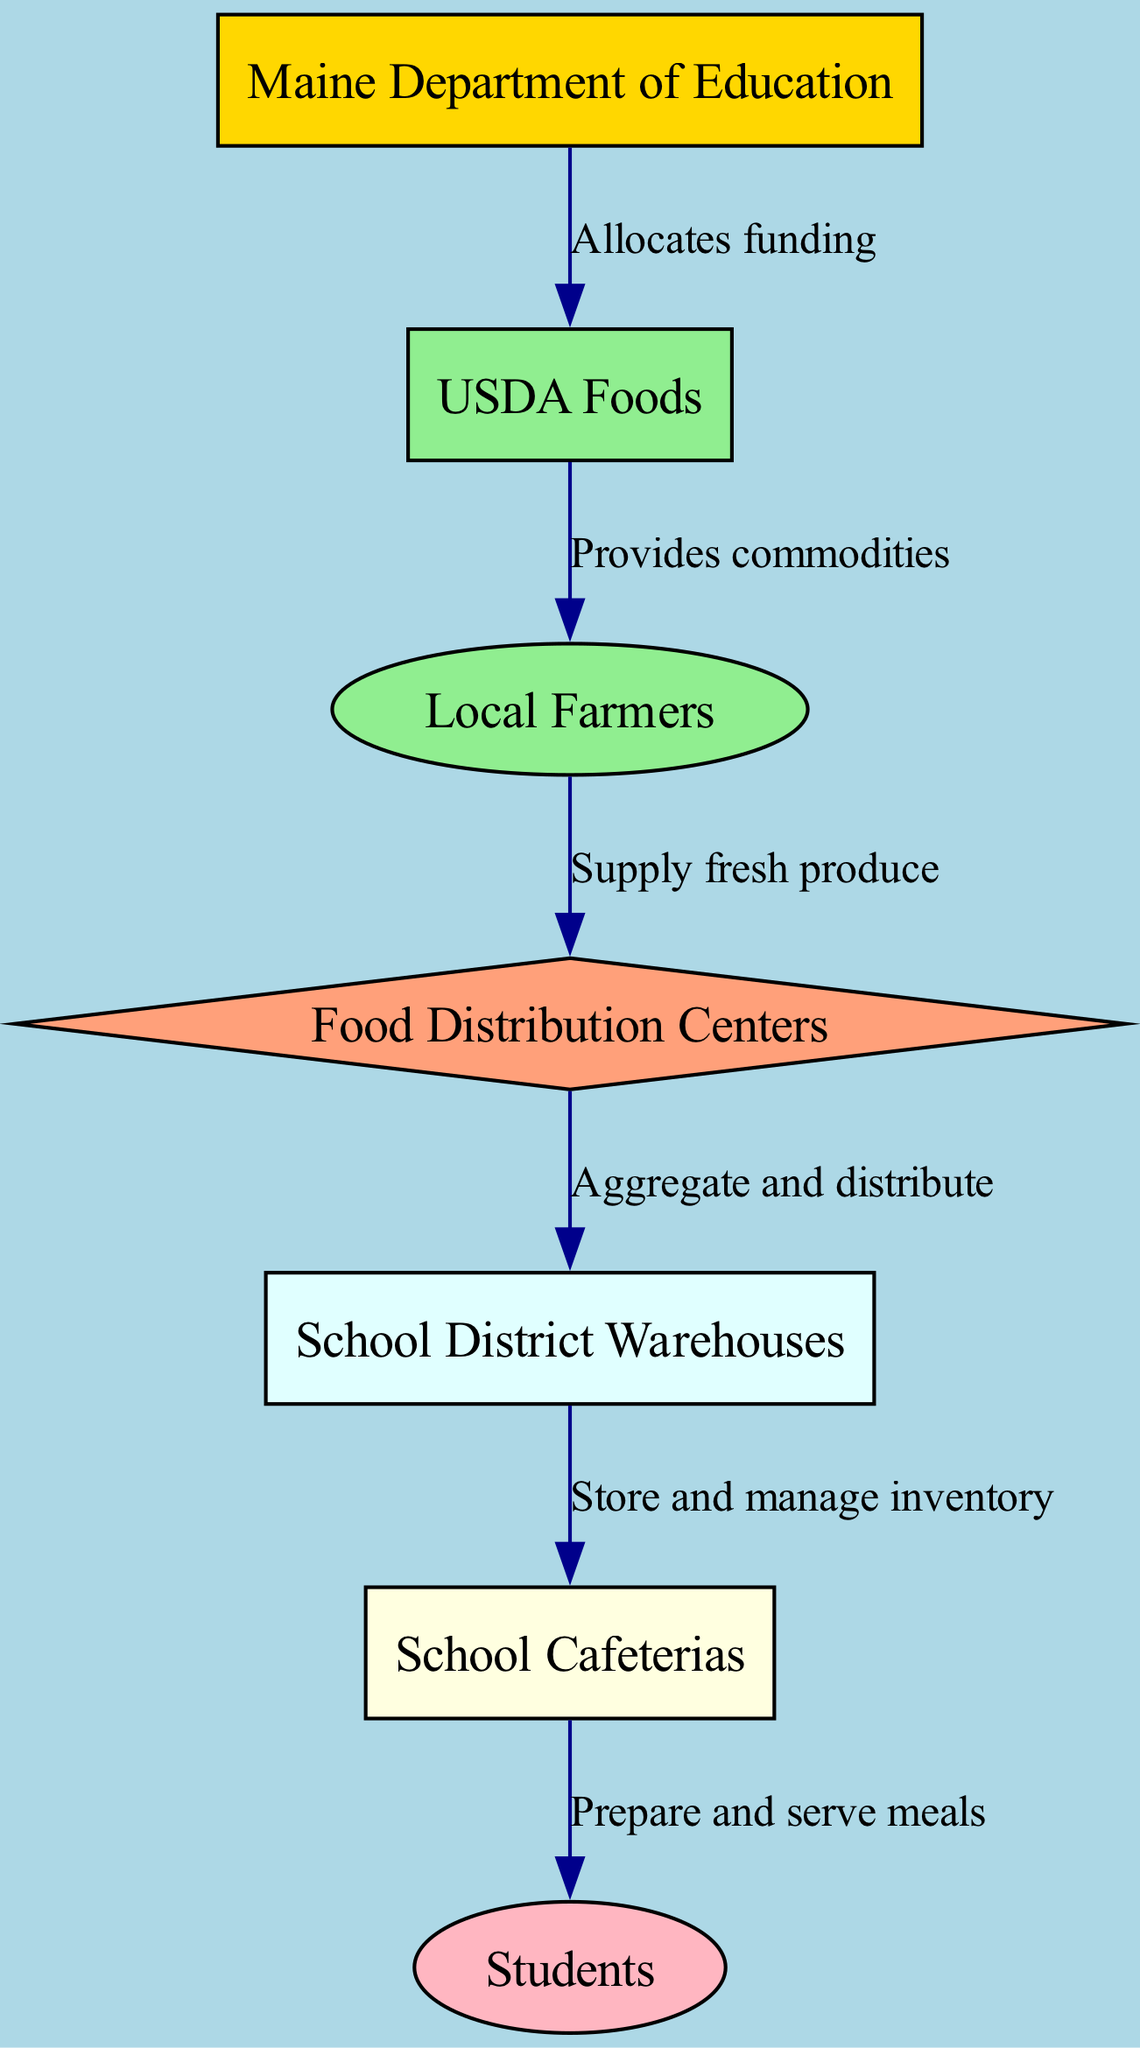What is the first node in the diagram? The first node listed in the diagram is "Maine Department of Education". This can be identified by looking at the top of the flow of the nodes, which systematically starts with this node.
Answer: Maine Department of Education How many nodes are there in total? The total number of nodes in the diagram can be counted from the provided list. There are seven nodes: "Maine Department of Education", "USDA Foods", "Local Farmers", "Food Distribution Centers", "School District Warehouses", "School Cafeterias", and "Students".
Answer: 7 Which node receives funding from the Maine Department of Education? The edge connecting "Maine Department of Education" to "USDA Foods" indicates that it allocates funding specifically to this node. This relationship clearly points out where the funding goes.
Answer: USDA Foods What do Local Farmers supply to the food distribution network? The relationship from "Local Farmers" to "Food Distribution Centers" shows that they supply fresh produce. This connection indicates the specific type of contribution made by local farmers in the network.
Answer: Fresh produce Which node is last in the flow of the diagram? The last node in the sequence is "Students", which is positioned at the bottom of the flow diagram, indicating that it is the final recipient of the school lunch program meals.
Answer: Students What is the purpose of the Food Distribution Centers? The edge indicates that "Food Distribution Centers" aggregate and distribute food, describing their function within the network clearly. This shows their role in managing food between suppliers and schools.
Answer: Aggregate and distribute Explain the relationship between School District Warehouses and School Cafeterias. The edge states that "School District Warehouses" store and manage inventory, which is then utilized in "School Cafeterias" where meals are prepared and served. This indicates a flow of inventory management to meal preparation.
Answer: Store and manage inventory How many edges are in the diagram? By counting the connections between the nodes, we can see that there are six edges present: each representing the relationship between consecutive nodes.
Answer: 6 What node directly consumes meals? The node labeled "Students" is directly connected to the final activity of consuming meals. This shows their role as the end-user in this food distribution network.
Answer: Students 